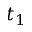<formula> <loc_0><loc_0><loc_500><loc_500>t _ { 1 }</formula> 